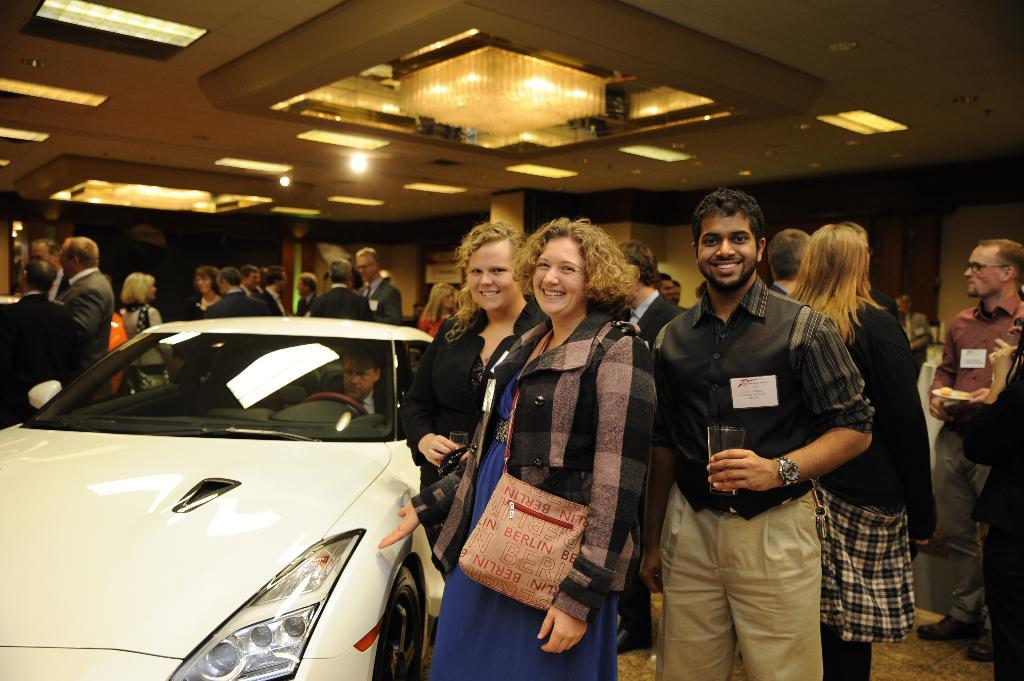What is the main subject of the image? The main subject of the image is a car. What is happening around the car in the image? There is a group of people around the car in the image. What can be seen at the top of the image? There are lights visible at the top of the image. What type of coal is being used to fuel the car in the image? There is no coal present in the image, and the car is not being fueled by coal. How does the health of the people around the car affect the image? The health of the people around the car is not mentioned or depicted in the image, so it cannot be determined how it might affect the image. 